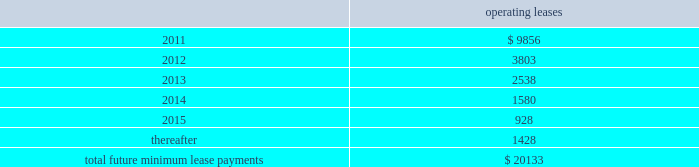Notes to consolidated financial statements 2014 ( continued ) note 14 2014commitments and contingencies leases we conduct a major part of our operations using leased facilities and equipment .
Many of these leases have renewal and purchase options and provide that we pay the cost of property taxes , insurance and maintenance .
Rent expense on all operating leases for fiscal 2010 , 2009 and 2008 was $ 32.8 million , $ 30.2 million , and $ 30.4 million , respectively .
Future minimum lease payments for all noncancelable leases at may 31 , 2010 were as follows : operating leases .
We are party to a number of claims and lawsuits incidental to our business .
In the opinion of management , the reasonably possible outcome of such matters , individually or in the aggregate , will not have a material adverse impact on our financial position , liquidity or results of operations .
We define operating taxes as tax contingencies that are unrelated to income taxes , such as sales and property taxes .
During the course of operations , we must interpret the meaning of various operating tax matters in the united states and in the foreign jurisdictions in which we do business .
Taxing authorities in those various jurisdictions may arrive at different interpretations of applicable tax laws and regulations as they relate to such operating tax matters , which could result in the payment of additional taxes in those jurisdictions .
As of may 31 , 2010 and 2009 we did not have a liability for operating tax items .
The amount of the liability is based on management 2019s best estimate given our history with similar matters and interpretations of current laws and regulations .
Bin/ica agreements in connection with our acquisition of merchant credit card operations of banks , we have entered into sponsorship or depository and processing agreements with certain of the banks .
These agreements allow us to use the banks 2019 identification numbers , referred to as bank identification number for visa transactions and interbank card association number for mastercard transactions , to clear credit card transactions through visa and mastercard .
Certain of such agreements contain financial covenants , and we were in compliance with all such covenants as of may 31 , 2010 .
On june 18 , 2010 , cibc provided notice that it will not renew its sponsorship with us for visa in canada after the initial ten year term .
As a result , their canadian visa sponsorship will expire in march 2011 .
We are .
What was the total rent expense on all operating leases for fiscal 2008 through 2010 in millions? 
Computations: ((32.8 + 30.2) + 30.4)
Answer: 93.4. 